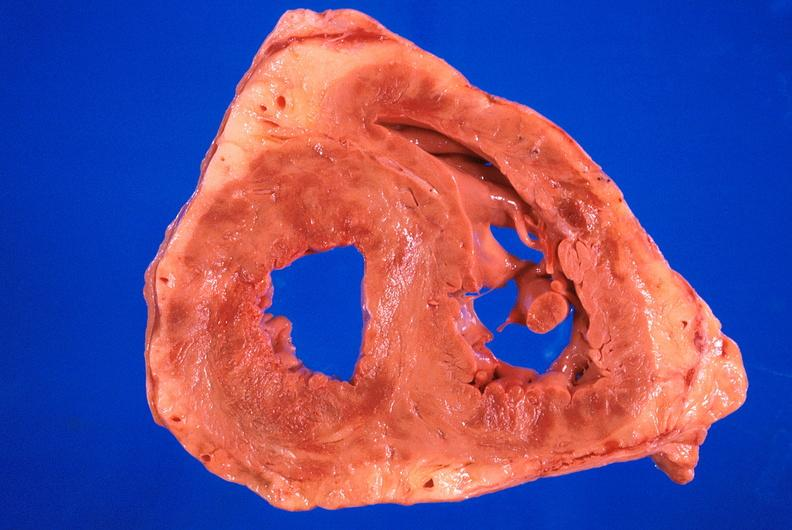where is this?
Answer the question using a single word or phrase. Heart 